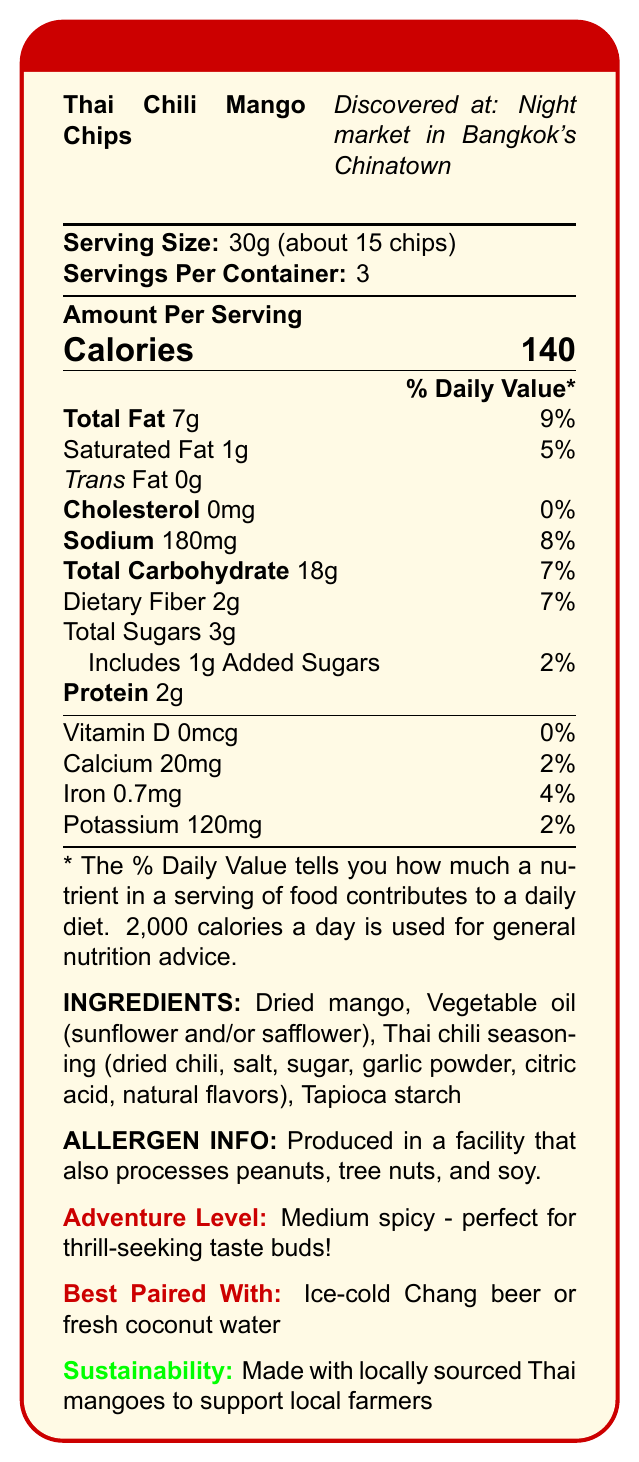what is the product name? The product name is explicitly mentioned in the document's heading.
Answer: Thai Chili Mango Chips how many servings are in one container? The document states that there are 3 servings per container.
Answer: 3 how many calories are in one serving? The document lists "Calories" as 140 per serving.
Answer: 140 what is the amount of dietary fiber per serving? Dietary fiber content is indicated as 2g per serving.
Answer: 2g how much vitamin D is in each serving? The amount of vitamin D is listed as 0mcg.
Answer: 0mcg which ingredient is not part of the Thai chili seasoning? A. Dried chili B. Garlic powder C. Citric acid D. Olive oil The ingredients of the Thai chili seasoning do not include olive oil; it includes dried chili, garlic powder, and citric acid.
Answer: D how much sodium is in each serving? A. 90mg B. 120mg C. 180mg D. 220mg The document states sodium content per serving is 180mg.
Answer: C is there any cholesterol in the product? Cholesterol is stated as 0mg, which means there is no cholesterol in the product.
Answer: No which of the following best describes the flavor profile? A. Sweet and tangy B. Bland and salty C. Spicy and savory The document describes the flavor profile as "Sweet and tangy mango with a fiery kick of Thai chili".
Answer: A give a brief summary of the document. The document's main content includes nutritional breakdown, flavor profile, adventure level, serving size, pairing recommendations, texture, and sustainability info about the Thai Chili Mango Chips.
Answer: The document provides the nutrition facts and additional information about Thai Chili Mango Chips. It includes serving details, ingredient information, allergen warnings, and recommended pairings. The chips offer a medium spicy adventure level and are made with locally sourced Thai mangoes. what is the best drink pairing according to the document? The document suggests that the snack pairs best with ice-cold Chang beer or fresh coconut water.
Answer: Ice-cold Chang beer or fresh coconut water how much calcium is provided per serving? The document lists calcium content as 20mg per serving.
Answer: 20mg what is the texture of the snack? The texture is described as "Crispy and light" in the document.
Answer: Crispy and light is the document recyclable? It specifies that the snack comes in a recyclable foil pouch with a resealable zip-top.
Answer: Yes who is the manufacturer of the Thai Chili Mango Chips? The manufacturer is mentioned as Bangkok Street Snacks Co., Ltd.
Answer: Bangkok Street Snacks Co., Ltd. can you tell if the chips are locally sourced? The document states, "Made with locally sourced Thai mangoes to support local farmers."
Answer: Yes what is the adventure level of the Thai Chili Mango Chips? A. Mild B. Medium C. Hot The document clearly states that the adventure level is medium spicy.
Answer: B how many total carbs are in a whole container? Each serving has 18g of total carbohydrates, and with 3 servings per container, the total is 18g x 3 = 54g.
Answer: 54g do the ingredients contain any peanuts? While the document indicates that the product is made in a facility that also processes peanuts, peanuts are not listed as an ingredient.
Answer: No are there any instructions on how to make the chips? The document does not provide instructions on how to make the chips.
Answer: Not enough information 